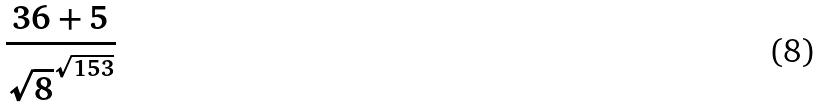Convert formula to latex. <formula><loc_0><loc_0><loc_500><loc_500>\frac { 3 6 + 5 } { \sqrt { 8 } ^ { \sqrt { 1 5 3 } } }</formula> 